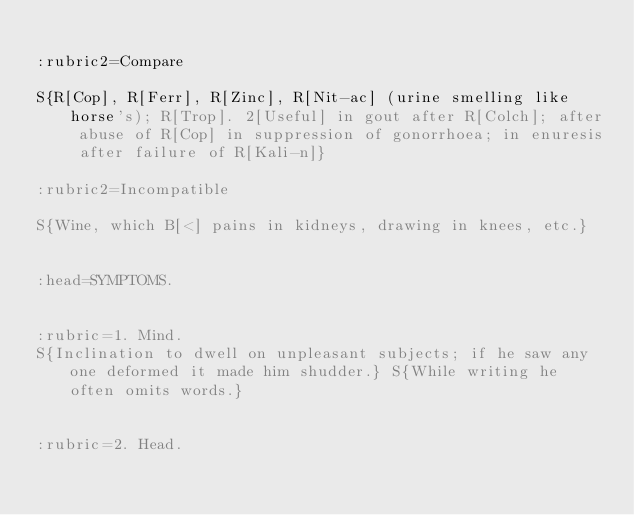<code> <loc_0><loc_0><loc_500><loc_500><_ObjectiveC_>
:rubric2=Compare

S{R[Cop], R[Ferr], R[Zinc], R[Nit-ac] (urine smelling like horse's); R[Trop]. 2[Useful] in gout after R[Colch]; after abuse of R[Cop] in suppression of gonorrhoea; in enuresis after failure of R[Kali-n]}

:rubric2=Incompatible

S{Wine, which B[<] pains in kidneys, drawing in knees, etc.}


:head=SYMPTOMS.


:rubric=1. Mind.
S{Inclination to dwell on unpleasant subjects; if he saw any one deformed it made him shudder.} S{While writing he often omits words.}


:rubric=2. Head.</code> 